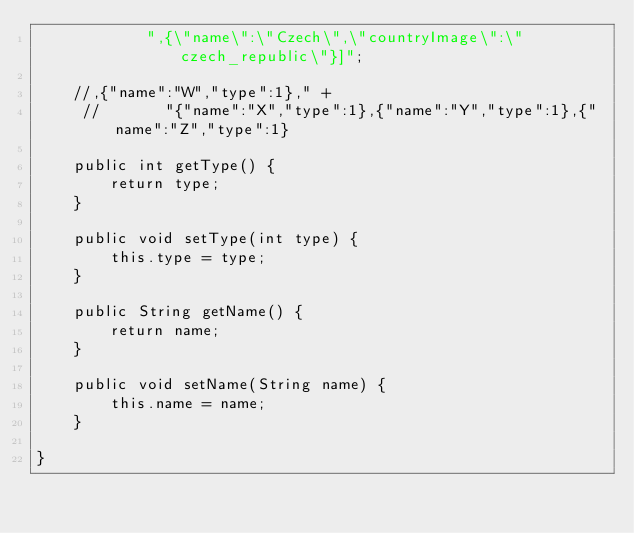Convert code to text. <code><loc_0><loc_0><loc_500><loc_500><_Java_>            ",{\"name\":\"Czech\",\"countryImage\":\"czech_republic\"}]";

    //,{"name":"W","type":1}," +
     //       "{"name":"X","type":1},{"name":"Y","type":1},{"name":"Z","type":1}

    public int getType() {
        return type;
    }

    public void setType(int type) {
        this.type = type;
    }

    public String getName() {
        return name;
    }

    public void setName(String name) {
        this.name = name;
    }

}
</code> 